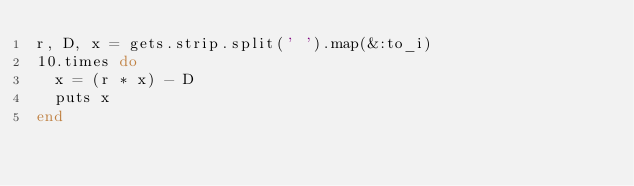Convert code to text. <code><loc_0><loc_0><loc_500><loc_500><_Ruby_>r, D, x = gets.strip.split(' ').map(&:to_i)
10.times do
  x = (r * x) - D
  puts x
end</code> 